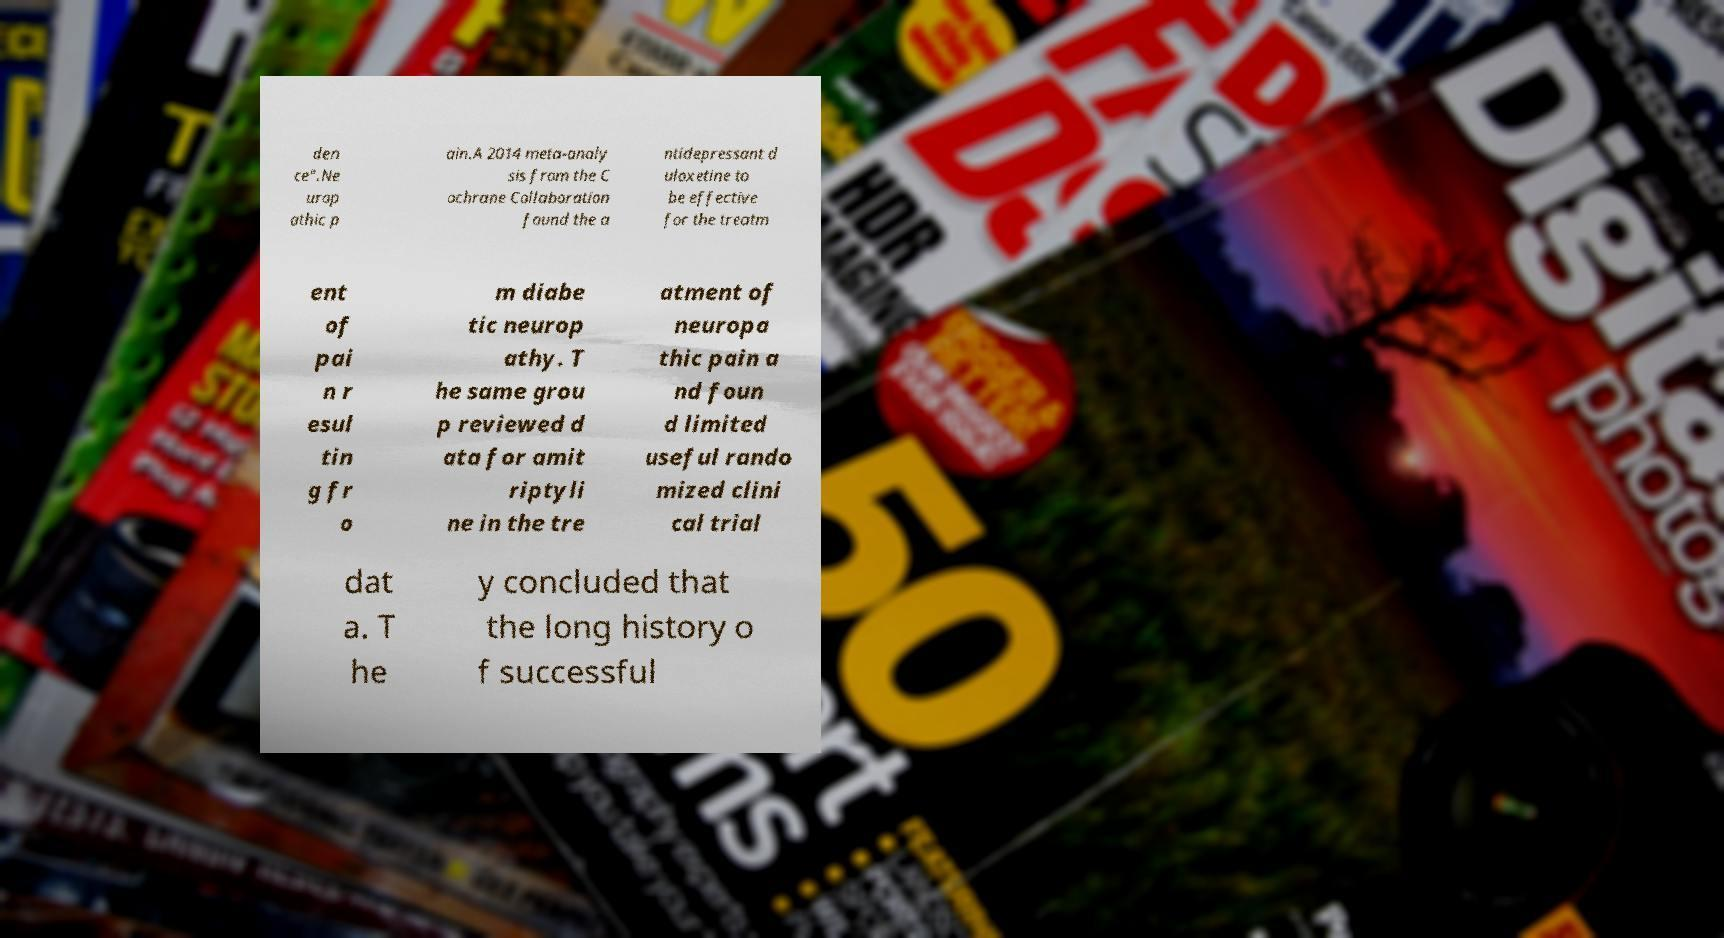Please read and relay the text visible in this image. What does it say? den ce".Ne urop athic p ain.A 2014 meta-analy sis from the C ochrane Collaboration found the a ntidepressant d uloxetine to be effective for the treatm ent of pai n r esul tin g fr o m diabe tic neurop athy. T he same grou p reviewed d ata for amit riptyli ne in the tre atment of neuropa thic pain a nd foun d limited useful rando mized clini cal trial dat a. T he y concluded that the long history o f successful 